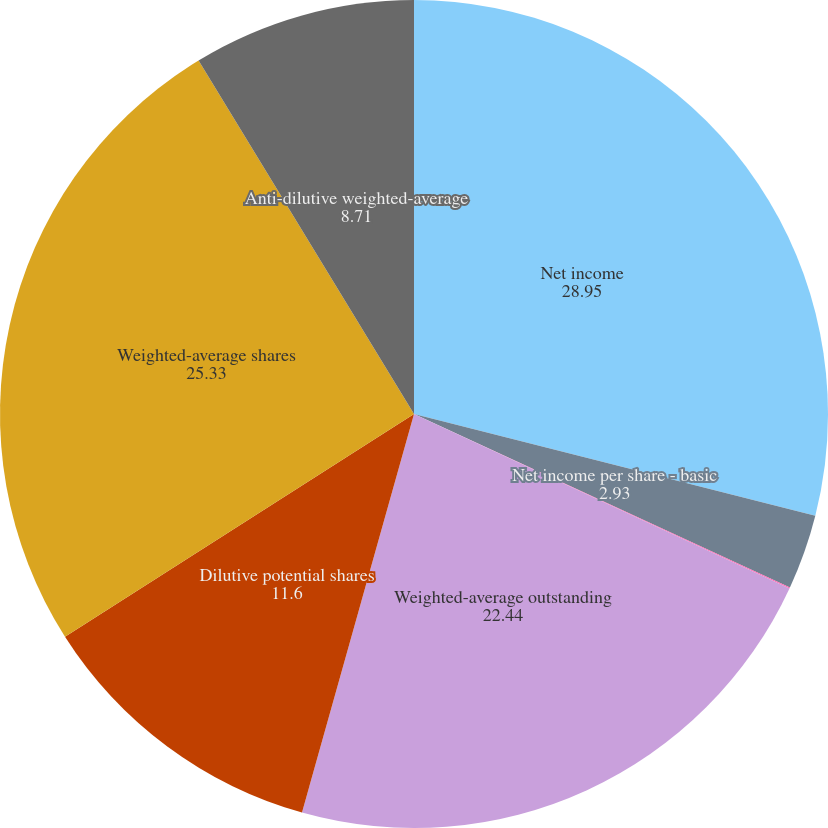Convert chart to OTSL. <chart><loc_0><loc_0><loc_500><loc_500><pie_chart><fcel>Net income<fcel>Net income per share - basic<fcel>Net income per share - diluted<fcel>Weighted-average outstanding<fcel>Dilutive potential shares<fcel>Weighted-average shares<fcel>Anti-dilutive weighted-average<nl><fcel>28.95%<fcel>2.93%<fcel>0.04%<fcel>22.44%<fcel>11.6%<fcel>25.33%<fcel>8.71%<nl></chart> 